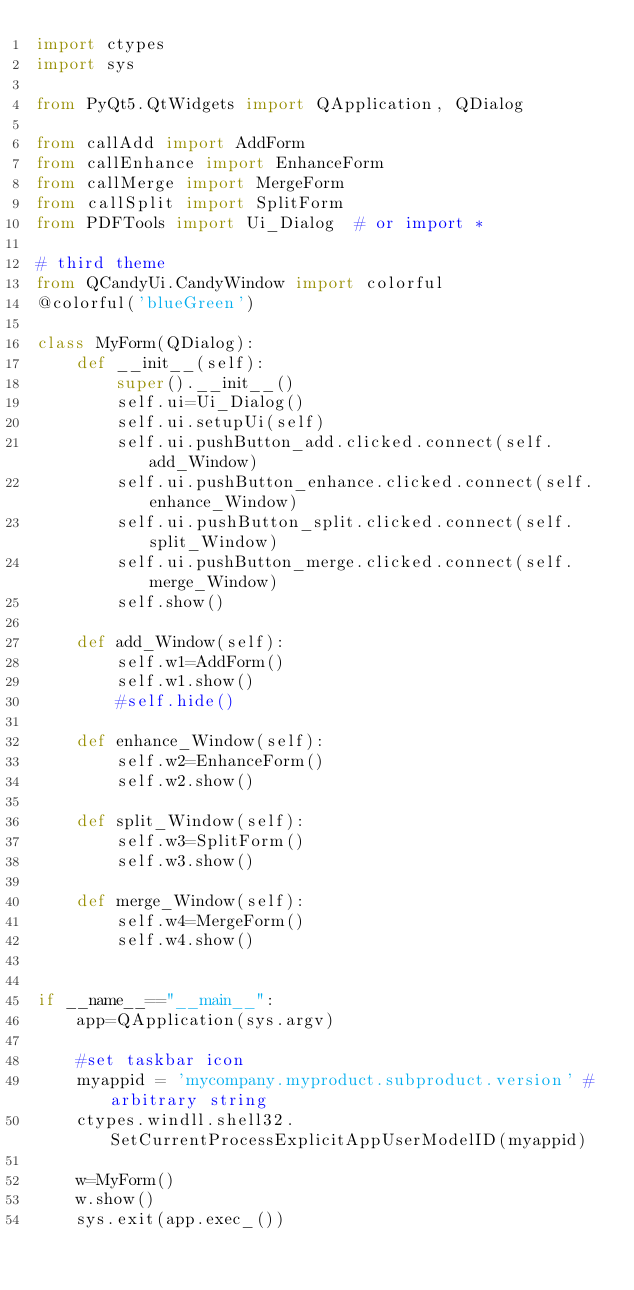<code> <loc_0><loc_0><loc_500><loc_500><_Python_>import ctypes
import sys

from PyQt5.QtWidgets import QApplication, QDialog

from callAdd import AddForm
from callEnhance import EnhanceForm
from callMerge import MergeForm
from callSplit import SplitForm
from PDFTools import Ui_Dialog  # or import *

# third theme
from QCandyUi.CandyWindow import colorful
@colorful('blueGreen')

class MyForm(QDialog):
    def __init__(self):
        super().__init__()
        self.ui=Ui_Dialog()
        self.ui.setupUi(self)
        self.ui.pushButton_add.clicked.connect(self.add_Window)
        self.ui.pushButton_enhance.clicked.connect(self.enhance_Window)
        self.ui.pushButton_split.clicked.connect(self.split_Window)
        self.ui.pushButton_merge.clicked.connect(self.merge_Window)
        self.show()
    
    def add_Window(self):
        self.w1=AddForm()
        self.w1.show()
        #self.hide()
        
    def enhance_Window(self):
        self.w2=EnhanceForm()
        self.w2.show()
       
    def split_Window(self):
        self.w3=SplitForm()
        self.w3.show()
        
    def merge_Window(self):
        self.w4=MergeForm()
        self.w4.show()
      
        
if __name__=="__main__":
    app=QApplication(sys.argv)

    #set taskbar icon
    myappid = 'mycompany.myproduct.subproduct.version' # arbitrary string
    ctypes.windll.shell32.SetCurrentProcessExplicitAppUserModelID(myappid)

    w=MyForm()
    w.show()
    sys.exit(app.exec_())
</code> 